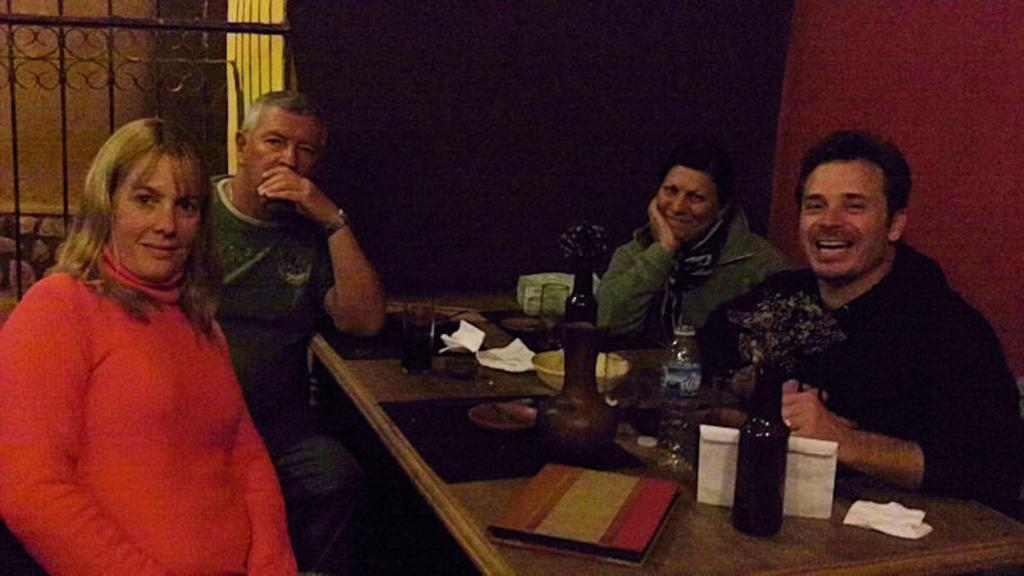What type of setting is depicted in the image? The image shows an inside view of a room. How many people are present in the room? There are four persons in the room. What are the persons wearing? The persons are wearing clothes. What are the persons doing in the image? The persons are sitting in front of a table. What items can be seen on the table? The table contains bottles, glasses, and a bowl. What type of art can be seen hanging on the walls in the image? There is no art visible on the walls in the image. How many cushions are present on the chairs in the image? There is no mention of cushions on the chairs in the image. 